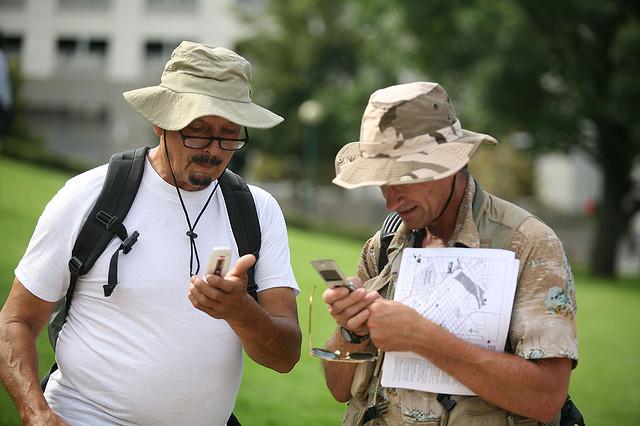What are the men's ranks?
Write a very short answer. None. What do the men appear to be looking at?
Be succinct. Cell phones. What is the gender of the two individuals?
Keep it brief. Male. What is the color pattern on the right hat called?
Write a very short answer. Camouflage. 